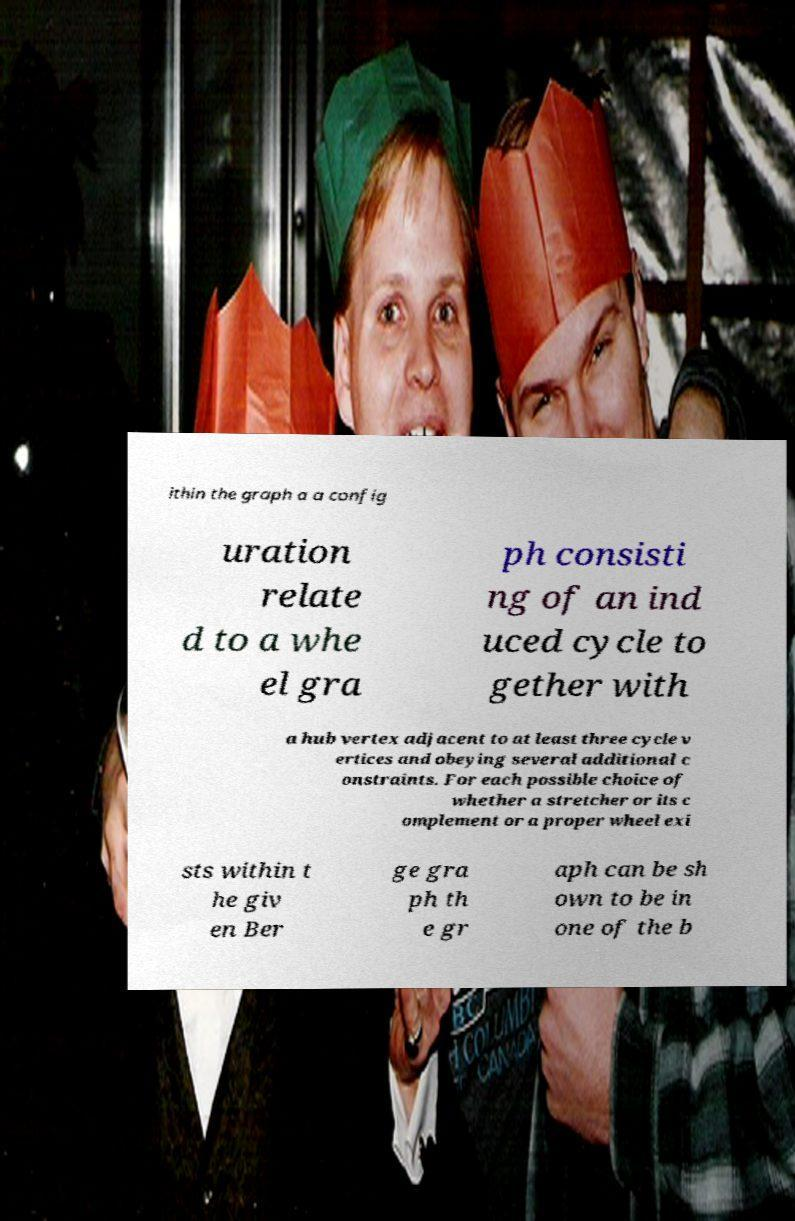Please read and relay the text visible in this image. What does it say? ithin the graph a a config uration relate d to a whe el gra ph consisti ng of an ind uced cycle to gether with a hub vertex adjacent to at least three cycle v ertices and obeying several additional c onstraints. For each possible choice of whether a stretcher or its c omplement or a proper wheel exi sts within t he giv en Ber ge gra ph th e gr aph can be sh own to be in one of the b 